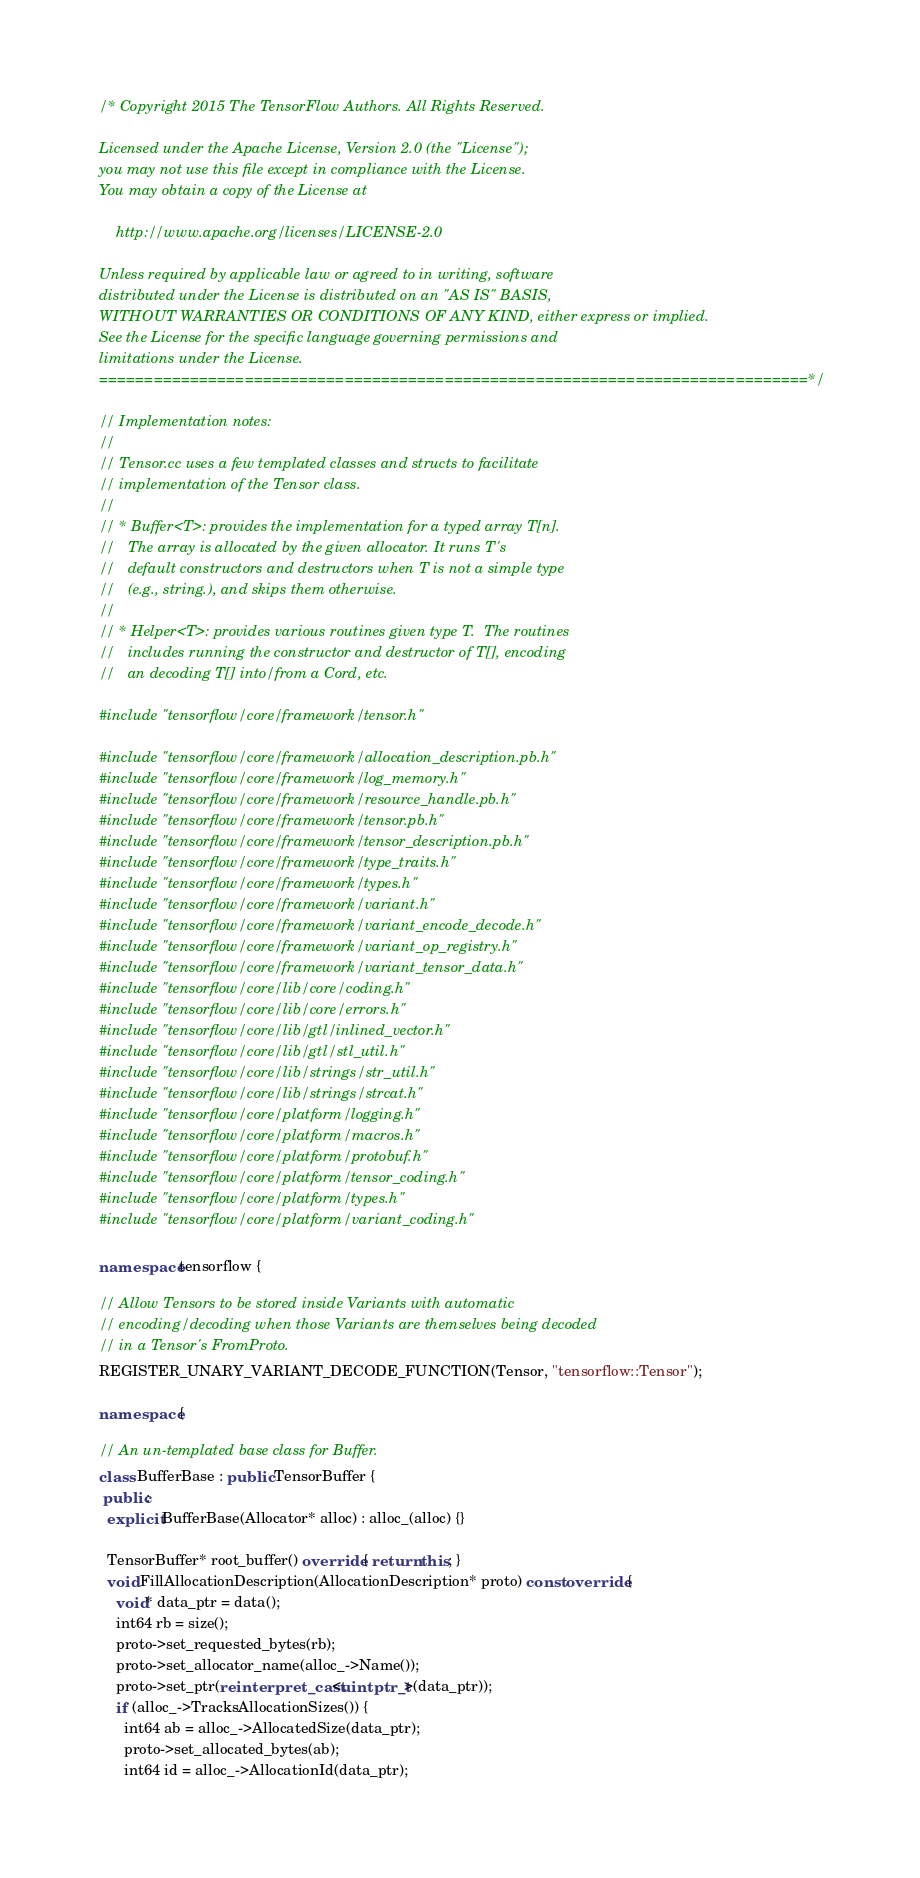Convert code to text. <code><loc_0><loc_0><loc_500><loc_500><_C++_>/* Copyright 2015 The TensorFlow Authors. All Rights Reserved.

Licensed under the Apache License, Version 2.0 (the "License");
you may not use this file except in compliance with the License.
You may obtain a copy of the License at

    http://www.apache.org/licenses/LICENSE-2.0

Unless required by applicable law or agreed to in writing, software
distributed under the License is distributed on an "AS IS" BASIS,
WITHOUT WARRANTIES OR CONDITIONS OF ANY KIND, either express or implied.
See the License for the specific language governing permissions and
limitations under the License.
==============================================================================*/

// Implementation notes:
//
// Tensor.cc uses a few templated classes and structs to facilitate
// implementation of the Tensor class.
//
// * Buffer<T>: provides the implementation for a typed array T[n].
//   The array is allocated by the given allocator. It runs T's
//   default constructors and destructors when T is not a simple type
//   (e.g., string.), and skips them otherwise.
//
// * Helper<T>: provides various routines given type T.  The routines
//   includes running the constructor and destructor of T[], encoding
//   an decoding T[] into/from a Cord, etc.

#include "tensorflow/core/framework/tensor.h"

#include "tensorflow/core/framework/allocation_description.pb.h"
#include "tensorflow/core/framework/log_memory.h"
#include "tensorflow/core/framework/resource_handle.pb.h"
#include "tensorflow/core/framework/tensor.pb.h"
#include "tensorflow/core/framework/tensor_description.pb.h"
#include "tensorflow/core/framework/type_traits.h"
#include "tensorflow/core/framework/types.h"
#include "tensorflow/core/framework/variant.h"
#include "tensorflow/core/framework/variant_encode_decode.h"
#include "tensorflow/core/framework/variant_op_registry.h"
#include "tensorflow/core/framework/variant_tensor_data.h"
#include "tensorflow/core/lib/core/coding.h"
#include "tensorflow/core/lib/core/errors.h"
#include "tensorflow/core/lib/gtl/inlined_vector.h"
#include "tensorflow/core/lib/gtl/stl_util.h"
#include "tensorflow/core/lib/strings/str_util.h"
#include "tensorflow/core/lib/strings/strcat.h"
#include "tensorflow/core/platform/logging.h"
#include "tensorflow/core/platform/macros.h"
#include "tensorflow/core/platform/protobuf.h"
#include "tensorflow/core/platform/tensor_coding.h"
#include "tensorflow/core/platform/types.h"
#include "tensorflow/core/platform/variant_coding.h"

namespace tensorflow {

// Allow Tensors to be stored inside Variants with automatic
// encoding/decoding when those Variants are themselves being decoded
// in a Tensor's FromProto.
REGISTER_UNARY_VARIANT_DECODE_FUNCTION(Tensor, "tensorflow::Tensor");

namespace {

// An un-templated base class for Buffer.
class BufferBase : public TensorBuffer {
 public:
  explicit BufferBase(Allocator* alloc) : alloc_(alloc) {}

  TensorBuffer* root_buffer() override { return this; }
  void FillAllocationDescription(AllocationDescription* proto) const override {
    void* data_ptr = data();
    int64 rb = size();
    proto->set_requested_bytes(rb);
    proto->set_allocator_name(alloc_->Name());
    proto->set_ptr(reinterpret_cast<uintptr_t>(data_ptr));
    if (alloc_->TracksAllocationSizes()) {
      int64 ab = alloc_->AllocatedSize(data_ptr);
      proto->set_allocated_bytes(ab);
      int64 id = alloc_->AllocationId(data_ptr);</code> 